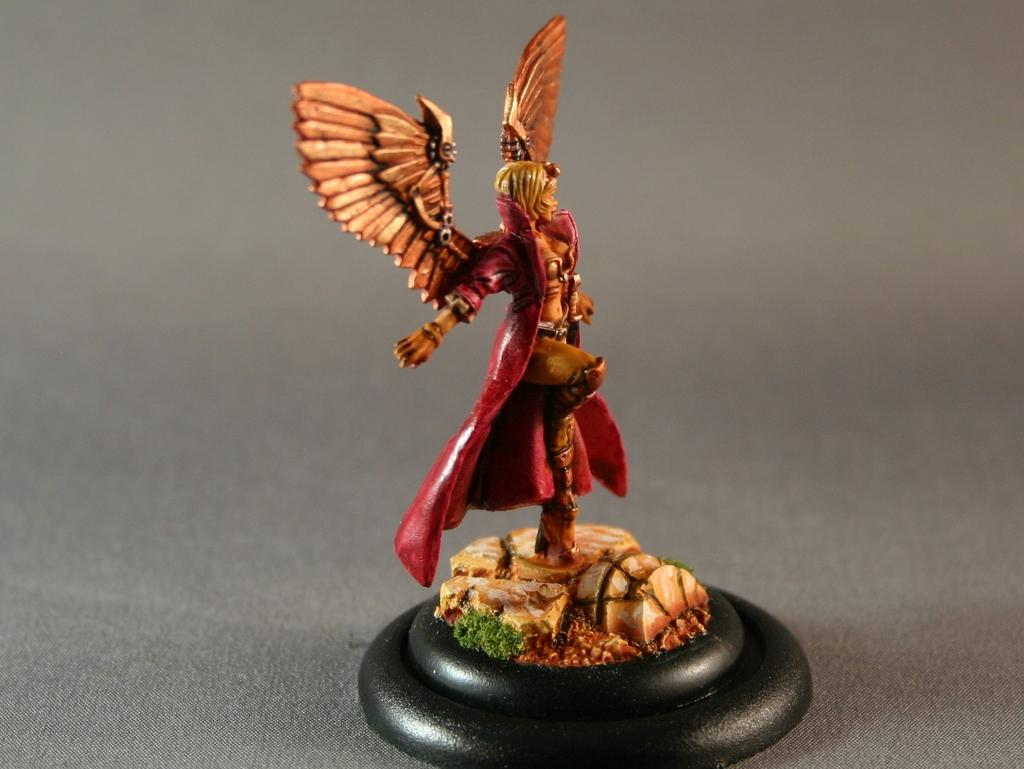What object is in the image that resembles a toy? There is a toy in the image. Where is the toy located in the image? The toy is placed on a table. How is the toy positioned on the table? The toy is in the center of the image. What type of nose can be seen on the toy in the image? There is no nose visible on the toy in the image. What type of agreement is being made between the toy and another object in the image? There is no agreement being made between the toy and another object in the image, as the toy is an inanimate object. 